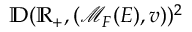Convert formula to latex. <formula><loc_0><loc_0><loc_500><loc_500>\mathbb { D } ( \mathbb { R } _ { + } , ( \mathcal { M } _ { F } ( E ) , v ) ) ^ { 2 }</formula> 